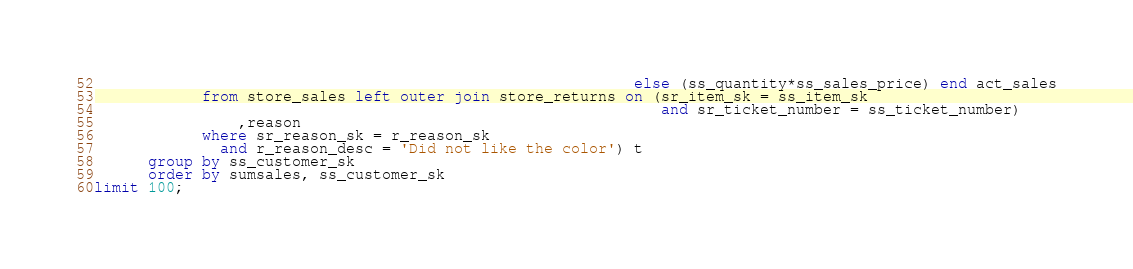Convert code to text. <code><loc_0><loc_0><loc_500><loc_500><_SQL_>                                                            else (ss_quantity*ss_sales_price) end act_sales
            from store_sales left outer join store_returns on (sr_item_sk = ss_item_sk
                                                               and sr_ticket_number = ss_ticket_number)
                ,reason
            where sr_reason_sk = r_reason_sk
              and r_reason_desc = 'Did not like the color') t
      group by ss_customer_sk
      order by sumsales, ss_customer_sk
limit 100;
</code> 